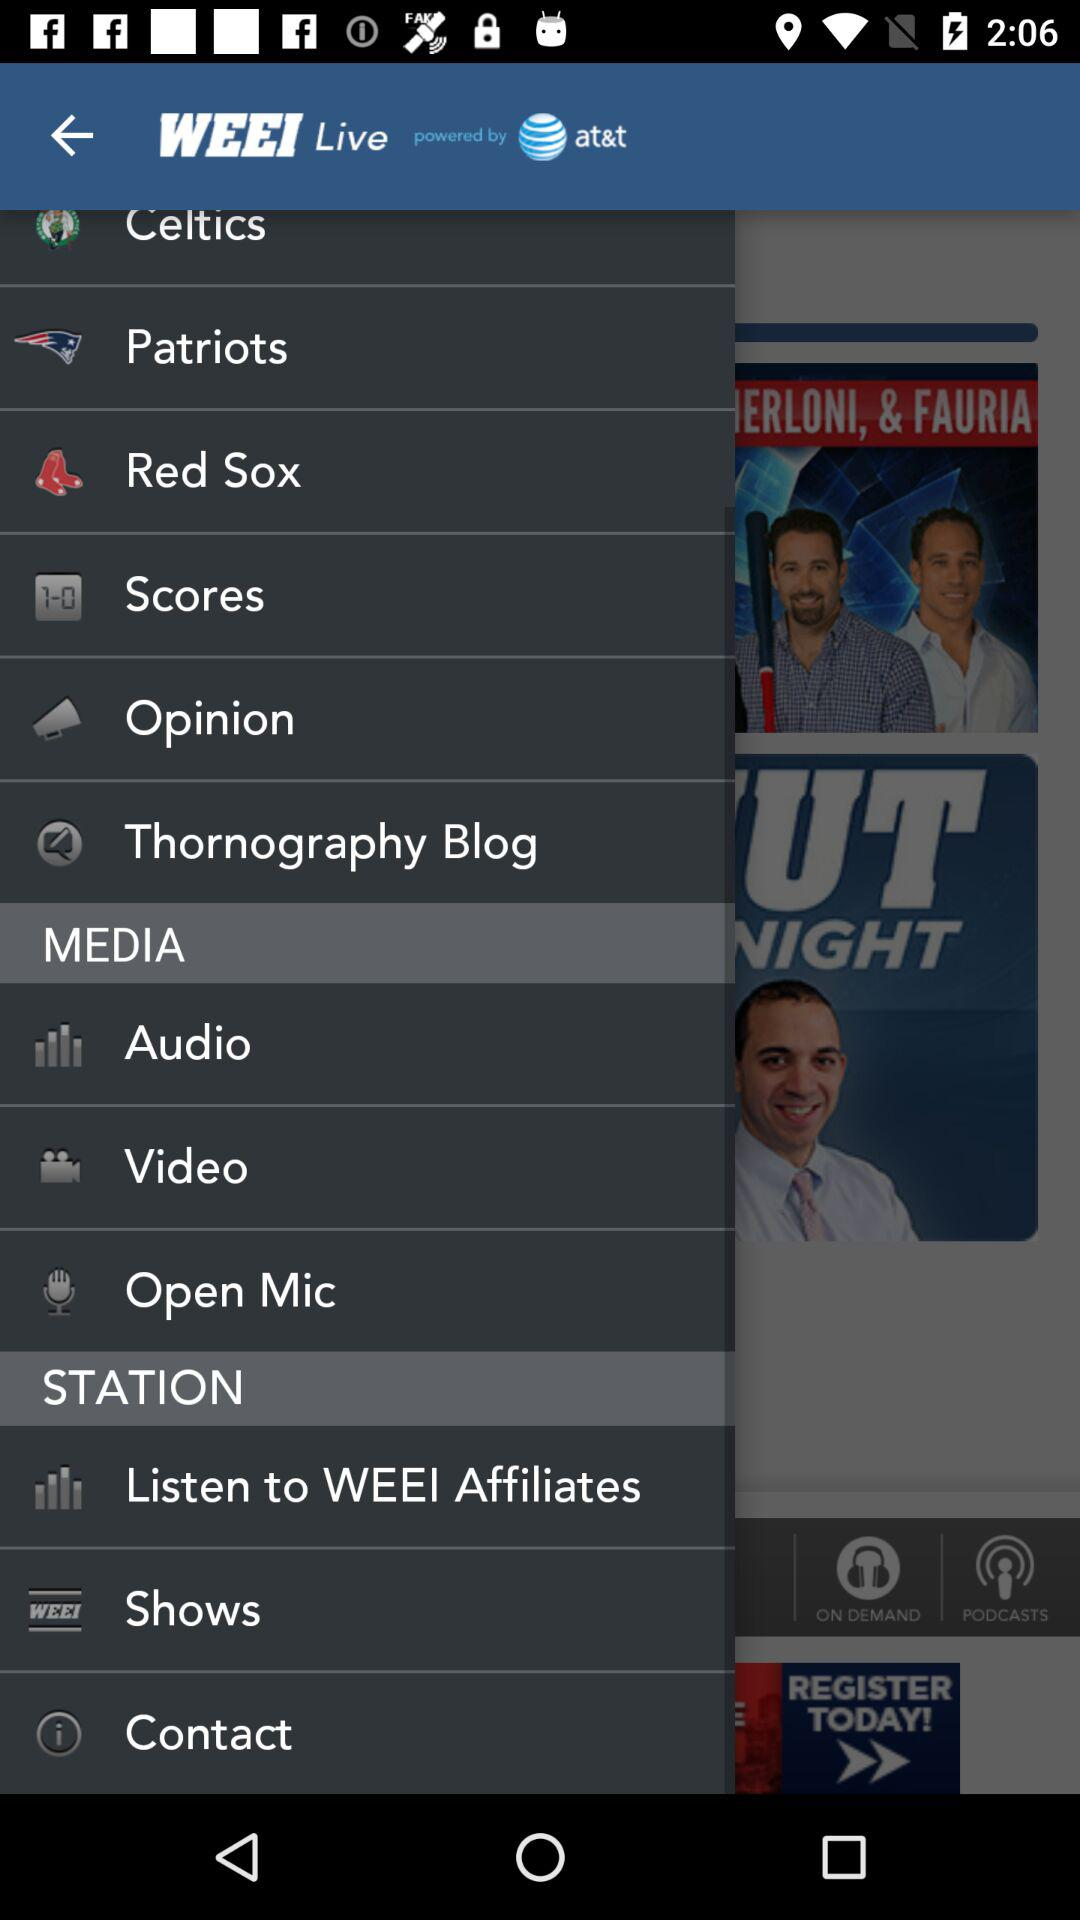Who developed the application?
When the provided information is insufficient, respond with <no answer>. <no answer> 